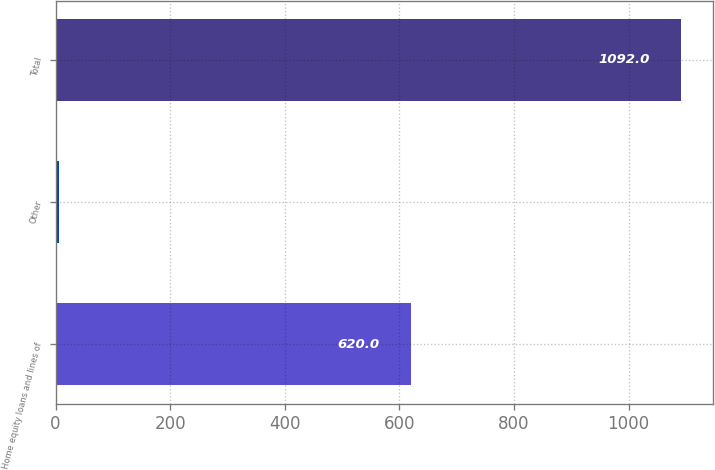Convert chart to OTSL. <chart><loc_0><loc_0><loc_500><loc_500><bar_chart><fcel>Home equity loans and lines of<fcel>Other<fcel>Total<nl><fcel>620<fcel>6<fcel>1092<nl></chart> 